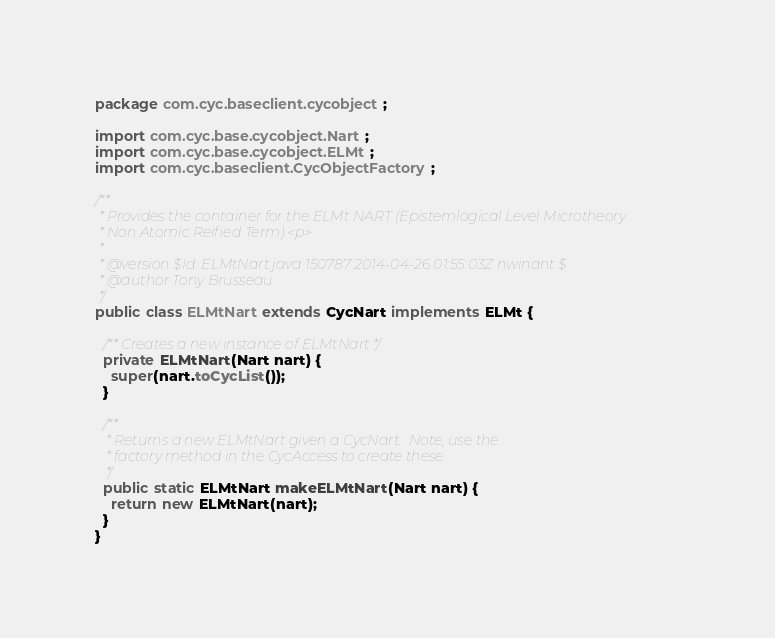Convert code to text. <code><loc_0><loc_0><loc_500><loc_500><_Java_>package com.cyc.baseclient.cycobject;

import com.cyc.base.cycobject.Nart;
import com.cyc.base.cycobject.ELMt;
import com.cyc.baseclient.CycObjectFactory;

/**
 * Provides the container for the ELMt NART (Epistemlogical Level Microtheory
 * Non Atomic Reified Term).<p>
 *
 * @version $Id: ELMtNart.java 150787 2014-04-26 01:55:03Z nwinant $
 * @author Tony Brusseau
 */
public class ELMtNart extends CycNart implements ELMt {
  
  /** Creates a new instance of ELMtNart */
  private ELMtNart(Nart nart) {
    super(nart.toCycList());
  }
  
  /**
   * Returns a new ELMtNart given a CycNart.  Note, use the
   * factory method in the CycAccess to create these.
   */
  public static ELMtNart makeELMtNart(Nart nart) {
    return new ELMtNart(nart);
  }
}
</code> 